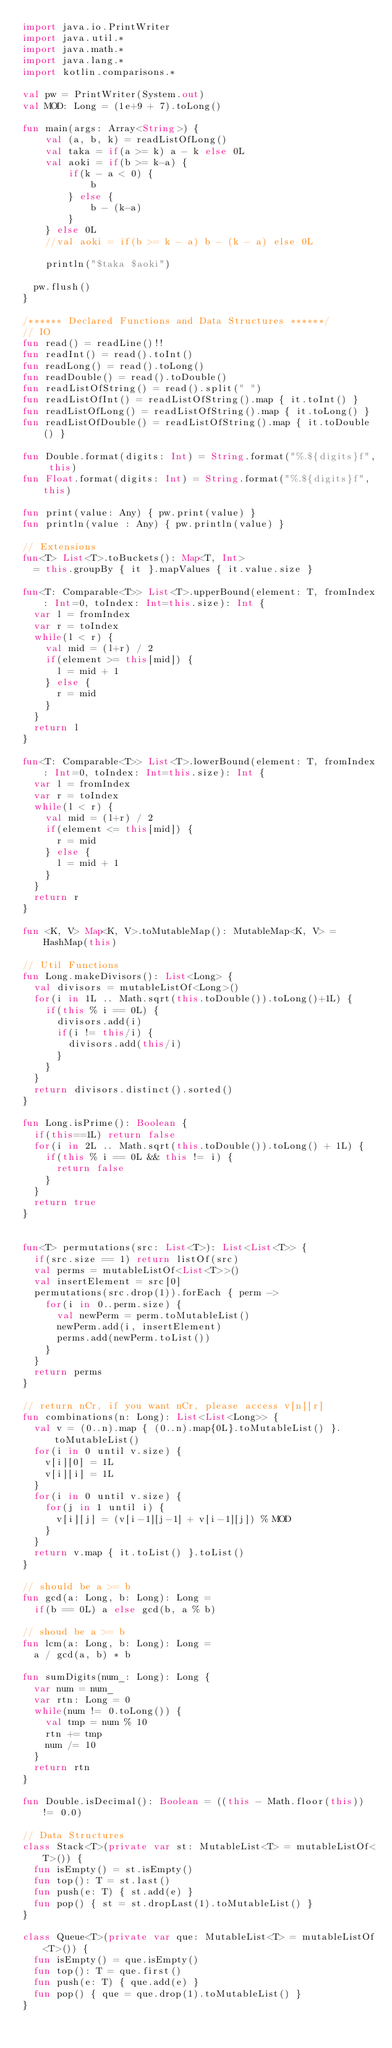Convert code to text. <code><loc_0><loc_0><loc_500><loc_500><_Kotlin_>import java.io.PrintWriter
import java.util.*
import java.math.*
import java.lang.*
import kotlin.comparisons.*

val pw = PrintWriter(System.out)
val MOD: Long = (1e+9 + 7).toLong()

fun main(args: Array<String>) {
    val (a, b, k) = readListOfLong()
    val taka = if(a >= k) a - k else 0L
    val aoki = if(b >= k-a) {
        if(k - a < 0) {
            b
        } else {
            b - (k-a)
        }
    } else 0L
    //val aoki = if(b >= k - a) b - (k - a) else 0L

    println("$taka $aoki")

	pw.flush()
}

/****** Declared Functions and Data Structures ******/
// IO
fun read() = readLine()!!
fun readInt() = read().toInt()
fun readLong() = read().toLong()
fun readDouble() = read().toDouble()
fun readListOfString() = read().split(" ")
fun readListOfInt() = readListOfString().map { it.toInt() }
fun readListOfLong() = readListOfString().map { it.toLong() }
fun readListOfDouble() = readListOfString().map { it.toDouble() }

fun Double.format(digits: Int) = String.format("%.${digits}f", this)
fun Float.format(digits: Int) = String.format("%.${digits}f", this)

fun print(value: Any) { pw.print(value) }
fun println(value : Any) { pw.println(value) }

// Extensions
fun<T> List<T>.toBuckets(): Map<T, Int>
	= this.groupBy { it }.mapValues { it.value.size }

fun<T: Comparable<T>> List<T>.upperBound(element: T, fromIndex: Int=0, toIndex: Int=this.size): Int {
	var l = fromIndex
	var r = toIndex
	while(l < r) {
		val mid = (l+r) / 2
		if(element >= this[mid]) { 
			l = mid + 1
		} else {
			r = mid
		}
	}
	return l
}

fun<T: Comparable<T>> List<T>.lowerBound(element: T, fromIndex: Int=0, toIndex: Int=this.size): Int {
	var l = fromIndex
	var r = toIndex
	while(l < r) {
		val mid = (l+r) / 2
		if(element <= this[mid]) { 
			r = mid
		} else {
			l = mid + 1
		}
	}
	return r 
}

fun <K, V> Map<K, V>.toMutableMap(): MutableMap<K, V> = HashMap(this)

// Util Functions
fun Long.makeDivisors(): List<Long> {
	val divisors = mutableListOf<Long>()
	for(i in 1L .. Math.sqrt(this.toDouble()).toLong()+1L) {
		if(this % i == 0L) {
			divisors.add(i)
			if(i != this/i) {
				divisors.add(this/i)
			}
		}
	}
	return divisors.distinct().sorted()
}

fun Long.isPrime(): Boolean {
	if(this==1L) return false
	for(i in 2L .. Math.sqrt(this.toDouble()).toLong() + 1L) {
		if(this % i == 0L && this != i) {
			return false
		}
	}
	return true
}


fun<T> permutations(src: List<T>): List<List<T>> {
	if(src.size == 1) return listOf(src)
	val perms = mutableListOf<List<T>>()
	val insertElement = src[0]
	permutations(src.drop(1)).forEach { perm ->
		for(i in 0..perm.size) {
			val newPerm = perm.toMutableList()
			newPerm.add(i, insertElement)
			perms.add(newPerm.toList())
		}
	}
	return perms
}

// return nCr, if you want nCr, please access v[n][r]
fun combinations(n: Long): List<List<Long>> {
	val v = (0..n).map { (0..n).map{0L}.toMutableList() }.toMutableList()
	for(i in 0 until v.size) {
		v[i][0] = 1L
		v[i][i] = 1L
	}
	for(i in 0 until v.size) {
		for(j in 1 until i) {
			v[i][j] = (v[i-1][j-1] + v[i-1][j]) % MOD
		}
	}
	return v.map { it.toList() }.toList()
}

// should be a >= b
fun gcd(a: Long, b: Long): Long = 
	if(b == 0L) a else gcd(b, a % b)

// shoud be a >= b
fun lcm(a: Long, b: Long): Long = 
	a / gcd(a, b) * b

fun sumDigits(num_: Long): Long {
	var num = num_
	var rtn: Long = 0
	while(num != 0.toLong()) {
		val tmp = num % 10
		rtn += tmp
		num /= 10
	}
	return rtn
}

fun Double.isDecimal(): Boolean = ((this - Math.floor(this)) != 0.0)

// Data Structures
class Stack<T>(private var st: MutableList<T> = mutableListOf<T>()) {
	fun isEmpty() = st.isEmpty()
	fun top(): T = st.last()
	fun push(e: T) { st.add(e) }
	fun pop() { st = st.dropLast(1).toMutableList() }
}

class Queue<T>(private var que: MutableList<T> = mutableListOf<T>()) {
	fun isEmpty() = que.isEmpty()
	fun top(): T = que.first()
	fun push(e: T) { que.add(e) }
	fun pop() { que = que.drop(1).toMutableList() }
}
</code> 